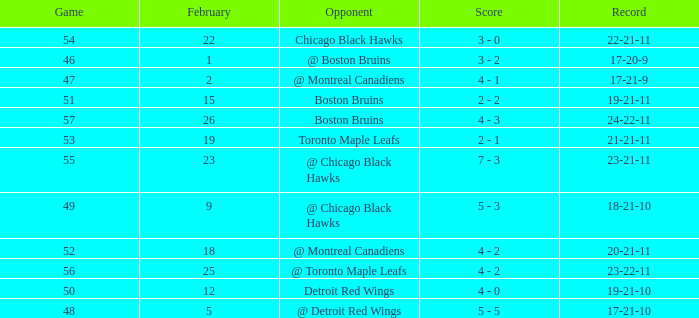What is the result of the game before 56 carried out after february 18 against the chicago black hawks? 3 - 0. 